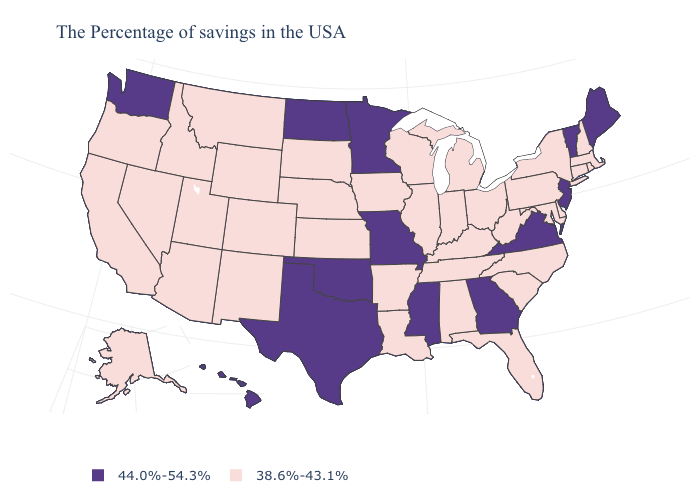Which states have the lowest value in the USA?
Write a very short answer. Massachusetts, Rhode Island, New Hampshire, Connecticut, New York, Delaware, Maryland, Pennsylvania, North Carolina, South Carolina, West Virginia, Ohio, Florida, Michigan, Kentucky, Indiana, Alabama, Tennessee, Wisconsin, Illinois, Louisiana, Arkansas, Iowa, Kansas, Nebraska, South Dakota, Wyoming, Colorado, New Mexico, Utah, Montana, Arizona, Idaho, Nevada, California, Oregon, Alaska. What is the value of Minnesota?
Short answer required. 44.0%-54.3%. Name the states that have a value in the range 38.6%-43.1%?
Keep it brief. Massachusetts, Rhode Island, New Hampshire, Connecticut, New York, Delaware, Maryland, Pennsylvania, North Carolina, South Carolina, West Virginia, Ohio, Florida, Michigan, Kentucky, Indiana, Alabama, Tennessee, Wisconsin, Illinois, Louisiana, Arkansas, Iowa, Kansas, Nebraska, South Dakota, Wyoming, Colorado, New Mexico, Utah, Montana, Arizona, Idaho, Nevada, California, Oregon, Alaska. Which states hav the highest value in the West?
Give a very brief answer. Washington, Hawaii. Is the legend a continuous bar?
Quick response, please. No. What is the value of Pennsylvania?
Be succinct. 38.6%-43.1%. What is the value of Minnesota?
Give a very brief answer. 44.0%-54.3%. Name the states that have a value in the range 38.6%-43.1%?
Concise answer only. Massachusetts, Rhode Island, New Hampshire, Connecticut, New York, Delaware, Maryland, Pennsylvania, North Carolina, South Carolina, West Virginia, Ohio, Florida, Michigan, Kentucky, Indiana, Alabama, Tennessee, Wisconsin, Illinois, Louisiana, Arkansas, Iowa, Kansas, Nebraska, South Dakota, Wyoming, Colorado, New Mexico, Utah, Montana, Arizona, Idaho, Nevada, California, Oregon, Alaska. Name the states that have a value in the range 44.0%-54.3%?
Quick response, please. Maine, Vermont, New Jersey, Virginia, Georgia, Mississippi, Missouri, Minnesota, Oklahoma, Texas, North Dakota, Washington, Hawaii. Name the states that have a value in the range 44.0%-54.3%?
Concise answer only. Maine, Vermont, New Jersey, Virginia, Georgia, Mississippi, Missouri, Minnesota, Oklahoma, Texas, North Dakota, Washington, Hawaii. What is the value of North Carolina?
Write a very short answer. 38.6%-43.1%. What is the value of Rhode Island?
Quick response, please. 38.6%-43.1%. What is the value of Oregon?
Be succinct. 38.6%-43.1%. Name the states that have a value in the range 44.0%-54.3%?
Answer briefly. Maine, Vermont, New Jersey, Virginia, Georgia, Mississippi, Missouri, Minnesota, Oklahoma, Texas, North Dakota, Washington, Hawaii. Which states have the lowest value in the South?
Quick response, please. Delaware, Maryland, North Carolina, South Carolina, West Virginia, Florida, Kentucky, Alabama, Tennessee, Louisiana, Arkansas. 